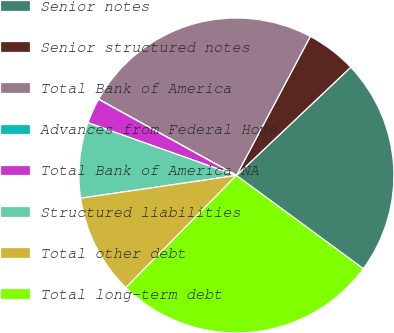<chart> <loc_0><loc_0><loc_500><loc_500><pie_chart><fcel>Senior notes<fcel>Senior structured notes<fcel>Total Bank of America<fcel>Advances from Federal Home<fcel>Total Bank of America NA<fcel>Structured liabilities<fcel>Total other debt<fcel>Total long-term debt<nl><fcel>22.15%<fcel>5.16%<fcel>24.73%<fcel>0.02%<fcel>2.59%<fcel>7.74%<fcel>10.31%<fcel>27.3%<nl></chart> 